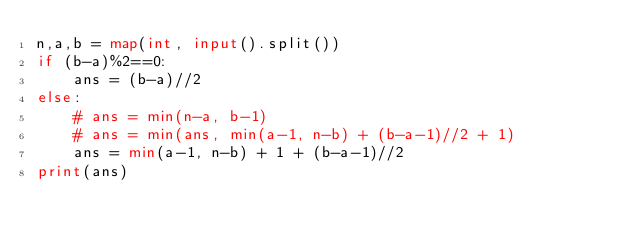<code> <loc_0><loc_0><loc_500><loc_500><_Python_>n,a,b = map(int, input().split())
if (b-a)%2==0:
    ans = (b-a)//2
else:
    # ans = min(n-a, b-1)
    # ans = min(ans, min(a-1, n-b) + (b-a-1)//2 + 1)
    ans = min(a-1, n-b) + 1 + (b-a-1)//2
print(ans)
</code> 